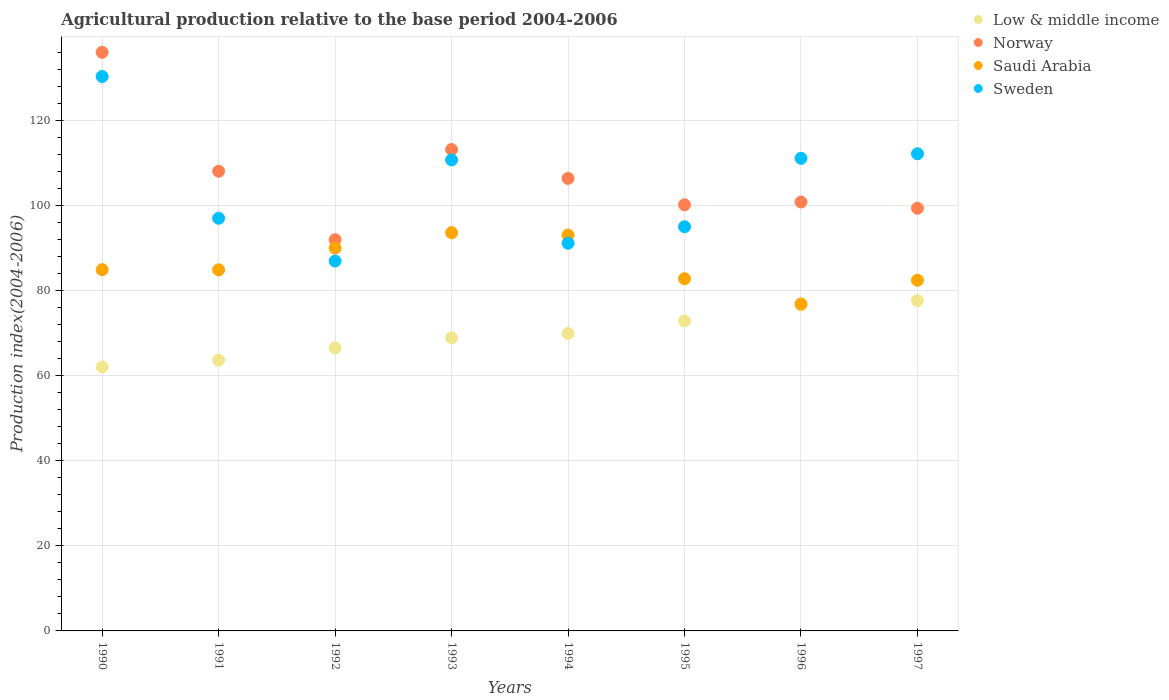How many different coloured dotlines are there?
Provide a short and direct response. 4. Is the number of dotlines equal to the number of legend labels?
Make the answer very short. Yes. What is the agricultural production index in Norway in 1992?
Provide a succinct answer. 91.99. Across all years, what is the maximum agricultural production index in Norway?
Offer a terse response. 136.05. Across all years, what is the minimum agricultural production index in Saudi Arabia?
Your answer should be compact. 76.88. In which year was the agricultural production index in Norway maximum?
Offer a terse response. 1990. What is the total agricultural production index in Norway in the graph?
Your answer should be compact. 856.15. What is the difference between the agricultural production index in Norway in 1994 and that in 1996?
Provide a short and direct response. 5.56. What is the difference between the agricultural production index in Norway in 1994 and the agricultural production index in Sweden in 1995?
Keep it short and to the point. 11.38. What is the average agricultural production index in Saudi Arabia per year?
Make the answer very short. 86.09. In the year 1991, what is the difference between the agricultural production index in Low & middle income and agricultural production index in Saudi Arabia?
Offer a terse response. -21.25. What is the ratio of the agricultural production index in Norway in 1990 to that in 1994?
Offer a terse response. 1.28. What is the difference between the highest and the second highest agricultural production index in Norway?
Make the answer very short. 22.86. What is the difference between the highest and the lowest agricultural production index in Low & middle income?
Your answer should be compact. 15.59. Is the sum of the agricultural production index in Sweden in 1990 and 1992 greater than the maximum agricultural production index in Saudi Arabia across all years?
Your response must be concise. Yes. Is it the case that in every year, the sum of the agricultural production index in Saudi Arabia and agricultural production index in Norway  is greater than the agricultural production index in Low & middle income?
Give a very brief answer. Yes. Is the agricultural production index in Norway strictly greater than the agricultural production index in Sweden over the years?
Provide a short and direct response. No. Is the agricultural production index in Saudi Arabia strictly less than the agricultural production index in Norway over the years?
Provide a short and direct response. Yes. How many dotlines are there?
Provide a short and direct response. 4. How many years are there in the graph?
Give a very brief answer. 8. Are the values on the major ticks of Y-axis written in scientific E-notation?
Provide a short and direct response. No. Does the graph contain any zero values?
Your answer should be very brief. No. Does the graph contain grids?
Give a very brief answer. Yes. How are the legend labels stacked?
Give a very brief answer. Vertical. What is the title of the graph?
Offer a very short reply. Agricultural production relative to the base period 2004-2006. What is the label or title of the X-axis?
Your answer should be very brief. Years. What is the label or title of the Y-axis?
Keep it short and to the point. Production index(2004-2006). What is the Production index(2004-2006) in Low & middle income in 1990?
Provide a succinct answer. 62.07. What is the Production index(2004-2006) in Norway in 1990?
Make the answer very short. 136.05. What is the Production index(2004-2006) of Saudi Arabia in 1990?
Ensure brevity in your answer.  84.94. What is the Production index(2004-2006) in Sweden in 1990?
Make the answer very short. 130.36. What is the Production index(2004-2006) in Low & middle income in 1991?
Offer a very short reply. 63.66. What is the Production index(2004-2006) in Norway in 1991?
Ensure brevity in your answer.  108.09. What is the Production index(2004-2006) of Saudi Arabia in 1991?
Offer a very short reply. 84.91. What is the Production index(2004-2006) in Sweden in 1991?
Keep it short and to the point. 97.03. What is the Production index(2004-2006) in Low & middle income in 1992?
Make the answer very short. 66.54. What is the Production index(2004-2006) of Norway in 1992?
Ensure brevity in your answer.  91.99. What is the Production index(2004-2006) in Saudi Arabia in 1992?
Offer a very short reply. 90.01. What is the Production index(2004-2006) in Sweden in 1992?
Provide a succinct answer. 86.97. What is the Production index(2004-2006) of Low & middle income in 1993?
Keep it short and to the point. 68.92. What is the Production index(2004-2006) of Norway in 1993?
Provide a succinct answer. 113.19. What is the Production index(2004-2006) of Saudi Arabia in 1993?
Offer a very short reply. 93.63. What is the Production index(2004-2006) in Sweden in 1993?
Your response must be concise. 110.75. What is the Production index(2004-2006) in Low & middle income in 1994?
Offer a terse response. 69.95. What is the Production index(2004-2006) of Norway in 1994?
Your response must be concise. 106.41. What is the Production index(2004-2006) of Saudi Arabia in 1994?
Make the answer very short. 93.08. What is the Production index(2004-2006) of Sweden in 1994?
Your response must be concise. 91.15. What is the Production index(2004-2006) of Low & middle income in 1995?
Provide a succinct answer. 72.89. What is the Production index(2004-2006) of Norway in 1995?
Make the answer very short. 100.19. What is the Production index(2004-2006) in Saudi Arabia in 1995?
Provide a short and direct response. 82.81. What is the Production index(2004-2006) of Sweden in 1995?
Your answer should be compact. 95.03. What is the Production index(2004-2006) of Low & middle income in 1996?
Ensure brevity in your answer.  76.63. What is the Production index(2004-2006) of Norway in 1996?
Offer a terse response. 100.85. What is the Production index(2004-2006) in Saudi Arabia in 1996?
Your response must be concise. 76.88. What is the Production index(2004-2006) of Sweden in 1996?
Offer a terse response. 111.12. What is the Production index(2004-2006) of Low & middle income in 1997?
Offer a very short reply. 77.67. What is the Production index(2004-2006) in Norway in 1997?
Offer a terse response. 99.38. What is the Production index(2004-2006) of Saudi Arabia in 1997?
Make the answer very short. 82.45. What is the Production index(2004-2006) in Sweden in 1997?
Give a very brief answer. 112.19. Across all years, what is the maximum Production index(2004-2006) in Low & middle income?
Give a very brief answer. 77.67. Across all years, what is the maximum Production index(2004-2006) of Norway?
Offer a very short reply. 136.05. Across all years, what is the maximum Production index(2004-2006) in Saudi Arabia?
Offer a terse response. 93.63. Across all years, what is the maximum Production index(2004-2006) in Sweden?
Offer a terse response. 130.36. Across all years, what is the minimum Production index(2004-2006) in Low & middle income?
Give a very brief answer. 62.07. Across all years, what is the minimum Production index(2004-2006) in Norway?
Offer a terse response. 91.99. Across all years, what is the minimum Production index(2004-2006) of Saudi Arabia?
Your response must be concise. 76.88. Across all years, what is the minimum Production index(2004-2006) of Sweden?
Offer a terse response. 86.97. What is the total Production index(2004-2006) in Low & middle income in the graph?
Give a very brief answer. 558.33. What is the total Production index(2004-2006) in Norway in the graph?
Provide a succinct answer. 856.15. What is the total Production index(2004-2006) in Saudi Arabia in the graph?
Make the answer very short. 688.71. What is the total Production index(2004-2006) in Sweden in the graph?
Provide a short and direct response. 834.6. What is the difference between the Production index(2004-2006) in Low & middle income in 1990 and that in 1991?
Your answer should be very brief. -1.59. What is the difference between the Production index(2004-2006) in Norway in 1990 and that in 1991?
Your response must be concise. 27.96. What is the difference between the Production index(2004-2006) of Saudi Arabia in 1990 and that in 1991?
Your answer should be compact. 0.03. What is the difference between the Production index(2004-2006) of Sweden in 1990 and that in 1991?
Keep it short and to the point. 33.33. What is the difference between the Production index(2004-2006) of Low & middle income in 1990 and that in 1992?
Provide a succinct answer. -4.47. What is the difference between the Production index(2004-2006) in Norway in 1990 and that in 1992?
Your answer should be compact. 44.06. What is the difference between the Production index(2004-2006) in Saudi Arabia in 1990 and that in 1992?
Provide a short and direct response. -5.07. What is the difference between the Production index(2004-2006) in Sweden in 1990 and that in 1992?
Ensure brevity in your answer.  43.39. What is the difference between the Production index(2004-2006) of Low & middle income in 1990 and that in 1993?
Provide a short and direct response. -6.85. What is the difference between the Production index(2004-2006) of Norway in 1990 and that in 1993?
Your answer should be compact. 22.86. What is the difference between the Production index(2004-2006) of Saudi Arabia in 1990 and that in 1993?
Offer a very short reply. -8.69. What is the difference between the Production index(2004-2006) in Sweden in 1990 and that in 1993?
Make the answer very short. 19.61. What is the difference between the Production index(2004-2006) in Low & middle income in 1990 and that in 1994?
Keep it short and to the point. -7.87. What is the difference between the Production index(2004-2006) of Norway in 1990 and that in 1994?
Provide a succinct answer. 29.64. What is the difference between the Production index(2004-2006) in Saudi Arabia in 1990 and that in 1994?
Provide a short and direct response. -8.14. What is the difference between the Production index(2004-2006) of Sweden in 1990 and that in 1994?
Provide a short and direct response. 39.21. What is the difference between the Production index(2004-2006) of Low & middle income in 1990 and that in 1995?
Make the answer very short. -10.82. What is the difference between the Production index(2004-2006) of Norway in 1990 and that in 1995?
Make the answer very short. 35.86. What is the difference between the Production index(2004-2006) in Saudi Arabia in 1990 and that in 1995?
Your answer should be compact. 2.13. What is the difference between the Production index(2004-2006) in Sweden in 1990 and that in 1995?
Offer a terse response. 35.33. What is the difference between the Production index(2004-2006) of Low & middle income in 1990 and that in 1996?
Keep it short and to the point. -14.56. What is the difference between the Production index(2004-2006) in Norway in 1990 and that in 1996?
Offer a terse response. 35.2. What is the difference between the Production index(2004-2006) in Saudi Arabia in 1990 and that in 1996?
Make the answer very short. 8.06. What is the difference between the Production index(2004-2006) in Sweden in 1990 and that in 1996?
Offer a terse response. 19.24. What is the difference between the Production index(2004-2006) in Low & middle income in 1990 and that in 1997?
Ensure brevity in your answer.  -15.59. What is the difference between the Production index(2004-2006) in Norway in 1990 and that in 1997?
Offer a terse response. 36.67. What is the difference between the Production index(2004-2006) in Saudi Arabia in 1990 and that in 1997?
Your answer should be very brief. 2.49. What is the difference between the Production index(2004-2006) of Sweden in 1990 and that in 1997?
Provide a succinct answer. 18.17. What is the difference between the Production index(2004-2006) of Low & middle income in 1991 and that in 1992?
Ensure brevity in your answer.  -2.88. What is the difference between the Production index(2004-2006) in Norway in 1991 and that in 1992?
Offer a terse response. 16.1. What is the difference between the Production index(2004-2006) in Sweden in 1991 and that in 1992?
Provide a succinct answer. 10.06. What is the difference between the Production index(2004-2006) of Low & middle income in 1991 and that in 1993?
Your answer should be compact. -5.26. What is the difference between the Production index(2004-2006) in Saudi Arabia in 1991 and that in 1993?
Offer a very short reply. -8.72. What is the difference between the Production index(2004-2006) of Sweden in 1991 and that in 1993?
Provide a short and direct response. -13.72. What is the difference between the Production index(2004-2006) in Low & middle income in 1991 and that in 1994?
Your response must be concise. -6.29. What is the difference between the Production index(2004-2006) in Norway in 1991 and that in 1994?
Keep it short and to the point. 1.68. What is the difference between the Production index(2004-2006) of Saudi Arabia in 1991 and that in 1994?
Offer a terse response. -8.17. What is the difference between the Production index(2004-2006) of Sweden in 1991 and that in 1994?
Offer a very short reply. 5.88. What is the difference between the Production index(2004-2006) of Low & middle income in 1991 and that in 1995?
Offer a terse response. -9.23. What is the difference between the Production index(2004-2006) of Saudi Arabia in 1991 and that in 1995?
Provide a short and direct response. 2.1. What is the difference between the Production index(2004-2006) in Sweden in 1991 and that in 1995?
Your answer should be compact. 2. What is the difference between the Production index(2004-2006) in Low & middle income in 1991 and that in 1996?
Give a very brief answer. -12.97. What is the difference between the Production index(2004-2006) of Norway in 1991 and that in 1996?
Keep it short and to the point. 7.24. What is the difference between the Production index(2004-2006) in Saudi Arabia in 1991 and that in 1996?
Ensure brevity in your answer.  8.03. What is the difference between the Production index(2004-2006) in Sweden in 1991 and that in 1996?
Your answer should be very brief. -14.09. What is the difference between the Production index(2004-2006) of Low & middle income in 1991 and that in 1997?
Provide a succinct answer. -14.01. What is the difference between the Production index(2004-2006) in Norway in 1991 and that in 1997?
Offer a very short reply. 8.71. What is the difference between the Production index(2004-2006) in Saudi Arabia in 1991 and that in 1997?
Provide a succinct answer. 2.46. What is the difference between the Production index(2004-2006) in Sweden in 1991 and that in 1997?
Make the answer very short. -15.16. What is the difference between the Production index(2004-2006) in Low & middle income in 1992 and that in 1993?
Offer a very short reply. -2.38. What is the difference between the Production index(2004-2006) in Norway in 1992 and that in 1993?
Ensure brevity in your answer.  -21.2. What is the difference between the Production index(2004-2006) in Saudi Arabia in 1992 and that in 1993?
Your answer should be very brief. -3.62. What is the difference between the Production index(2004-2006) of Sweden in 1992 and that in 1993?
Offer a terse response. -23.78. What is the difference between the Production index(2004-2006) of Low & middle income in 1992 and that in 1994?
Ensure brevity in your answer.  -3.41. What is the difference between the Production index(2004-2006) in Norway in 1992 and that in 1994?
Provide a short and direct response. -14.42. What is the difference between the Production index(2004-2006) in Saudi Arabia in 1992 and that in 1994?
Keep it short and to the point. -3.07. What is the difference between the Production index(2004-2006) in Sweden in 1992 and that in 1994?
Your response must be concise. -4.18. What is the difference between the Production index(2004-2006) of Low & middle income in 1992 and that in 1995?
Provide a short and direct response. -6.35. What is the difference between the Production index(2004-2006) of Norway in 1992 and that in 1995?
Your response must be concise. -8.2. What is the difference between the Production index(2004-2006) of Saudi Arabia in 1992 and that in 1995?
Your answer should be very brief. 7.2. What is the difference between the Production index(2004-2006) in Sweden in 1992 and that in 1995?
Provide a succinct answer. -8.06. What is the difference between the Production index(2004-2006) in Low & middle income in 1992 and that in 1996?
Ensure brevity in your answer.  -10.09. What is the difference between the Production index(2004-2006) in Norway in 1992 and that in 1996?
Your answer should be compact. -8.86. What is the difference between the Production index(2004-2006) in Saudi Arabia in 1992 and that in 1996?
Your answer should be very brief. 13.13. What is the difference between the Production index(2004-2006) of Sweden in 1992 and that in 1996?
Ensure brevity in your answer.  -24.15. What is the difference between the Production index(2004-2006) of Low & middle income in 1992 and that in 1997?
Your answer should be compact. -11.13. What is the difference between the Production index(2004-2006) of Norway in 1992 and that in 1997?
Offer a very short reply. -7.39. What is the difference between the Production index(2004-2006) in Saudi Arabia in 1992 and that in 1997?
Provide a succinct answer. 7.56. What is the difference between the Production index(2004-2006) of Sweden in 1992 and that in 1997?
Your answer should be very brief. -25.22. What is the difference between the Production index(2004-2006) of Low & middle income in 1993 and that in 1994?
Offer a terse response. -1.02. What is the difference between the Production index(2004-2006) of Norway in 1993 and that in 1994?
Give a very brief answer. 6.78. What is the difference between the Production index(2004-2006) in Saudi Arabia in 1993 and that in 1994?
Make the answer very short. 0.55. What is the difference between the Production index(2004-2006) of Sweden in 1993 and that in 1994?
Your answer should be very brief. 19.6. What is the difference between the Production index(2004-2006) of Low & middle income in 1993 and that in 1995?
Offer a very short reply. -3.97. What is the difference between the Production index(2004-2006) in Norway in 1993 and that in 1995?
Your answer should be compact. 13. What is the difference between the Production index(2004-2006) of Saudi Arabia in 1993 and that in 1995?
Your answer should be very brief. 10.82. What is the difference between the Production index(2004-2006) in Sweden in 1993 and that in 1995?
Your answer should be compact. 15.72. What is the difference between the Production index(2004-2006) in Low & middle income in 1993 and that in 1996?
Keep it short and to the point. -7.71. What is the difference between the Production index(2004-2006) in Norway in 1993 and that in 1996?
Your answer should be compact. 12.34. What is the difference between the Production index(2004-2006) of Saudi Arabia in 1993 and that in 1996?
Your answer should be compact. 16.75. What is the difference between the Production index(2004-2006) of Sweden in 1993 and that in 1996?
Ensure brevity in your answer.  -0.37. What is the difference between the Production index(2004-2006) in Low & middle income in 1993 and that in 1997?
Your answer should be very brief. -8.74. What is the difference between the Production index(2004-2006) in Norway in 1993 and that in 1997?
Offer a very short reply. 13.81. What is the difference between the Production index(2004-2006) of Saudi Arabia in 1993 and that in 1997?
Make the answer very short. 11.18. What is the difference between the Production index(2004-2006) of Sweden in 1993 and that in 1997?
Offer a terse response. -1.44. What is the difference between the Production index(2004-2006) of Low & middle income in 1994 and that in 1995?
Your answer should be very brief. -2.95. What is the difference between the Production index(2004-2006) of Norway in 1994 and that in 1995?
Provide a succinct answer. 6.22. What is the difference between the Production index(2004-2006) of Saudi Arabia in 1994 and that in 1995?
Your answer should be very brief. 10.27. What is the difference between the Production index(2004-2006) of Sweden in 1994 and that in 1995?
Your response must be concise. -3.88. What is the difference between the Production index(2004-2006) of Low & middle income in 1994 and that in 1996?
Offer a very short reply. -6.68. What is the difference between the Production index(2004-2006) of Norway in 1994 and that in 1996?
Provide a short and direct response. 5.56. What is the difference between the Production index(2004-2006) of Saudi Arabia in 1994 and that in 1996?
Your answer should be compact. 16.2. What is the difference between the Production index(2004-2006) of Sweden in 1994 and that in 1996?
Give a very brief answer. -19.97. What is the difference between the Production index(2004-2006) of Low & middle income in 1994 and that in 1997?
Your answer should be compact. -7.72. What is the difference between the Production index(2004-2006) in Norway in 1994 and that in 1997?
Your response must be concise. 7.03. What is the difference between the Production index(2004-2006) in Saudi Arabia in 1994 and that in 1997?
Offer a very short reply. 10.63. What is the difference between the Production index(2004-2006) of Sweden in 1994 and that in 1997?
Your answer should be very brief. -21.04. What is the difference between the Production index(2004-2006) of Low & middle income in 1995 and that in 1996?
Your answer should be very brief. -3.74. What is the difference between the Production index(2004-2006) of Norway in 1995 and that in 1996?
Make the answer very short. -0.66. What is the difference between the Production index(2004-2006) in Saudi Arabia in 1995 and that in 1996?
Provide a short and direct response. 5.93. What is the difference between the Production index(2004-2006) of Sweden in 1995 and that in 1996?
Your answer should be very brief. -16.09. What is the difference between the Production index(2004-2006) of Low & middle income in 1995 and that in 1997?
Your response must be concise. -4.77. What is the difference between the Production index(2004-2006) of Norway in 1995 and that in 1997?
Provide a short and direct response. 0.81. What is the difference between the Production index(2004-2006) in Saudi Arabia in 1995 and that in 1997?
Offer a very short reply. 0.36. What is the difference between the Production index(2004-2006) in Sweden in 1995 and that in 1997?
Ensure brevity in your answer.  -17.16. What is the difference between the Production index(2004-2006) in Low & middle income in 1996 and that in 1997?
Give a very brief answer. -1.04. What is the difference between the Production index(2004-2006) in Norway in 1996 and that in 1997?
Ensure brevity in your answer.  1.47. What is the difference between the Production index(2004-2006) of Saudi Arabia in 1996 and that in 1997?
Your answer should be very brief. -5.57. What is the difference between the Production index(2004-2006) of Sweden in 1996 and that in 1997?
Provide a short and direct response. -1.07. What is the difference between the Production index(2004-2006) in Low & middle income in 1990 and the Production index(2004-2006) in Norway in 1991?
Your answer should be very brief. -46.02. What is the difference between the Production index(2004-2006) in Low & middle income in 1990 and the Production index(2004-2006) in Saudi Arabia in 1991?
Offer a very short reply. -22.84. What is the difference between the Production index(2004-2006) of Low & middle income in 1990 and the Production index(2004-2006) of Sweden in 1991?
Ensure brevity in your answer.  -34.96. What is the difference between the Production index(2004-2006) in Norway in 1990 and the Production index(2004-2006) in Saudi Arabia in 1991?
Keep it short and to the point. 51.14. What is the difference between the Production index(2004-2006) of Norway in 1990 and the Production index(2004-2006) of Sweden in 1991?
Ensure brevity in your answer.  39.02. What is the difference between the Production index(2004-2006) of Saudi Arabia in 1990 and the Production index(2004-2006) of Sweden in 1991?
Your response must be concise. -12.09. What is the difference between the Production index(2004-2006) in Low & middle income in 1990 and the Production index(2004-2006) in Norway in 1992?
Ensure brevity in your answer.  -29.92. What is the difference between the Production index(2004-2006) of Low & middle income in 1990 and the Production index(2004-2006) of Saudi Arabia in 1992?
Offer a terse response. -27.94. What is the difference between the Production index(2004-2006) in Low & middle income in 1990 and the Production index(2004-2006) in Sweden in 1992?
Provide a succinct answer. -24.9. What is the difference between the Production index(2004-2006) of Norway in 1990 and the Production index(2004-2006) of Saudi Arabia in 1992?
Provide a short and direct response. 46.04. What is the difference between the Production index(2004-2006) in Norway in 1990 and the Production index(2004-2006) in Sweden in 1992?
Offer a terse response. 49.08. What is the difference between the Production index(2004-2006) of Saudi Arabia in 1990 and the Production index(2004-2006) of Sweden in 1992?
Provide a succinct answer. -2.03. What is the difference between the Production index(2004-2006) of Low & middle income in 1990 and the Production index(2004-2006) of Norway in 1993?
Your response must be concise. -51.12. What is the difference between the Production index(2004-2006) of Low & middle income in 1990 and the Production index(2004-2006) of Saudi Arabia in 1993?
Your response must be concise. -31.56. What is the difference between the Production index(2004-2006) of Low & middle income in 1990 and the Production index(2004-2006) of Sweden in 1993?
Give a very brief answer. -48.68. What is the difference between the Production index(2004-2006) in Norway in 1990 and the Production index(2004-2006) in Saudi Arabia in 1993?
Provide a short and direct response. 42.42. What is the difference between the Production index(2004-2006) in Norway in 1990 and the Production index(2004-2006) in Sweden in 1993?
Ensure brevity in your answer.  25.3. What is the difference between the Production index(2004-2006) in Saudi Arabia in 1990 and the Production index(2004-2006) in Sweden in 1993?
Your answer should be compact. -25.81. What is the difference between the Production index(2004-2006) of Low & middle income in 1990 and the Production index(2004-2006) of Norway in 1994?
Your answer should be compact. -44.34. What is the difference between the Production index(2004-2006) in Low & middle income in 1990 and the Production index(2004-2006) in Saudi Arabia in 1994?
Ensure brevity in your answer.  -31.01. What is the difference between the Production index(2004-2006) in Low & middle income in 1990 and the Production index(2004-2006) in Sweden in 1994?
Your answer should be very brief. -29.08. What is the difference between the Production index(2004-2006) of Norway in 1990 and the Production index(2004-2006) of Saudi Arabia in 1994?
Offer a terse response. 42.97. What is the difference between the Production index(2004-2006) in Norway in 1990 and the Production index(2004-2006) in Sweden in 1994?
Keep it short and to the point. 44.9. What is the difference between the Production index(2004-2006) in Saudi Arabia in 1990 and the Production index(2004-2006) in Sweden in 1994?
Give a very brief answer. -6.21. What is the difference between the Production index(2004-2006) of Low & middle income in 1990 and the Production index(2004-2006) of Norway in 1995?
Keep it short and to the point. -38.12. What is the difference between the Production index(2004-2006) of Low & middle income in 1990 and the Production index(2004-2006) of Saudi Arabia in 1995?
Ensure brevity in your answer.  -20.74. What is the difference between the Production index(2004-2006) of Low & middle income in 1990 and the Production index(2004-2006) of Sweden in 1995?
Offer a very short reply. -32.96. What is the difference between the Production index(2004-2006) of Norway in 1990 and the Production index(2004-2006) of Saudi Arabia in 1995?
Provide a succinct answer. 53.24. What is the difference between the Production index(2004-2006) in Norway in 1990 and the Production index(2004-2006) in Sweden in 1995?
Your answer should be very brief. 41.02. What is the difference between the Production index(2004-2006) of Saudi Arabia in 1990 and the Production index(2004-2006) of Sweden in 1995?
Provide a short and direct response. -10.09. What is the difference between the Production index(2004-2006) in Low & middle income in 1990 and the Production index(2004-2006) in Norway in 1996?
Provide a short and direct response. -38.78. What is the difference between the Production index(2004-2006) in Low & middle income in 1990 and the Production index(2004-2006) in Saudi Arabia in 1996?
Give a very brief answer. -14.81. What is the difference between the Production index(2004-2006) in Low & middle income in 1990 and the Production index(2004-2006) in Sweden in 1996?
Give a very brief answer. -49.05. What is the difference between the Production index(2004-2006) of Norway in 1990 and the Production index(2004-2006) of Saudi Arabia in 1996?
Offer a terse response. 59.17. What is the difference between the Production index(2004-2006) of Norway in 1990 and the Production index(2004-2006) of Sweden in 1996?
Offer a very short reply. 24.93. What is the difference between the Production index(2004-2006) in Saudi Arabia in 1990 and the Production index(2004-2006) in Sweden in 1996?
Your answer should be compact. -26.18. What is the difference between the Production index(2004-2006) of Low & middle income in 1990 and the Production index(2004-2006) of Norway in 1997?
Offer a terse response. -37.31. What is the difference between the Production index(2004-2006) of Low & middle income in 1990 and the Production index(2004-2006) of Saudi Arabia in 1997?
Your answer should be compact. -20.38. What is the difference between the Production index(2004-2006) of Low & middle income in 1990 and the Production index(2004-2006) of Sweden in 1997?
Provide a short and direct response. -50.12. What is the difference between the Production index(2004-2006) of Norway in 1990 and the Production index(2004-2006) of Saudi Arabia in 1997?
Make the answer very short. 53.6. What is the difference between the Production index(2004-2006) in Norway in 1990 and the Production index(2004-2006) in Sweden in 1997?
Make the answer very short. 23.86. What is the difference between the Production index(2004-2006) of Saudi Arabia in 1990 and the Production index(2004-2006) of Sweden in 1997?
Offer a terse response. -27.25. What is the difference between the Production index(2004-2006) of Low & middle income in 1991 and the Production index(2004-2006) of Norway in 1992?
Provide a succinct answer. -28.33. What is the difference between the Production index(2004-2006) of Low & middle income in 1991 and the Production index(2004-2006) of Saudi Arabia in 1992?
Ensure brevity in your answer.  -26.35. What is the difference between the Production index(2004-2006) in Low & middle income in 1991 and the Production index(2004-2006) in Sweden in 1992?
Make the answer very short. -23.31. What is the difference between the Production index(2004-2006) of Norway in 1991 and the Production index(2004-2006) of Saudi Arabia in 1992?
Your response must be concise. 18.08. What is the difference between the Production index(2004-2006) in Norway in 1991 and the Production index(2004-2006) in Sweden in 1992?
Offer a very short reply. 21.12. What is the difference between the Production index(2004-2006) of Saudi Arabia in 1991 and the Production index(2004-2006) of Sweden in 1992?
Offer a terse response. -2.06. What is the difference between the Production index(2004-2006) in Low & middle income in 1991 and the Production index(2004-2006) in Norway in 1993?
Offer a very short reply. -49.53. What is the difference between the Production index(2004-2006) in Low & middle income in 1991 and the Production index(2004-2006) in Saudi Arabia in 1993?
Ensure brevity in your answer.  -29.97. What is the difference between the Production index(2004-2006) of Low & middle income in 1991 and the Production index(2004-2006) of Sweden in 1993?
Provide a succinct answer. -47.09. What is the difference between the Production index(2004-2006) in Norway in 1991 and the Production index(2004-2006) in Saudi Arabia in 1993?
Offer a terse response. 14.46. What is the difference between the Production index(2004-2006) of Norway in 1991 and the Production index(2004-2006) of Sweden in 1993?
Your answer should be very brief. -2.66. What is the difference between the Production index(2004-2006) in Saudi Arabia in 1991 and the Production index(2004-2006) in Sweden in 1993?
Keep it short and to the point. -25.84. What is the difference between the Production index(2004-2006) of Low & middle income in 1991 and the Production index(2004-2006) of Norway in 1994?
Provide a short and direct response. -42.75. What is the difference between the Production index(2004-2006) in Low & middle income in 1991 and the Production index(2004-2006) in Saudi Arabia in 1994?
Provide a succinct answer. -29.42. What is the difference between the Production index(2004-2006) of Low & middle income in 1991 and the Production index(2004-2006) of Sweden in 1994?
Your answer should be compact. -27.49. What is the difference between the Production index(2004-2006) of Norway in 1991 and the Production index(2004-2006) of Saudi Arabia in 1994?
Ensure brevity in your answer.  15.01. What is the difference between the Production index(2004-2006) of Norway in 1991 and the Production index(2004-2006) of Sweden in 1994?
Your response must be concise. 16.94. What is the difference between the Production index(2004-2006) of Saudi Arabia in 1991 and the Production index(2004-2006) of Sweden in 1994?
Offer a terse response. -6.24. What is the difference between the Production index(2004-2006) of Low & middle income in 1991 and the Production index(2004-2006) of Norway in 1995?
Your answer should be very brief. -36.53. What is the difference between the Production index(2004-2006) of Low & middle income in 1991 and the Production index(2004-2006) of Saudi Arabia in 1995?
Provide a short and direct response. -19.15. What is the difference between the Production index(2004-2006) of Low & middle income in 1991 and the Production index(2004-2006) of Sweden in 1995?
Your answer should be compact. -31.37. What is the difference between the Production index(2004-2006) of Norway in 1991 and the Production index(2004-2006) of Saudi Arabia in 1995?
Keep it short and to the point. 25.28. What is the difference between the Production index(2004-2006) in Norway in 1991 and the Production index(2004-2006) in Sweden in 1995?
Give a very brief answer. 13.06. What is the difference between the Production index(2004-2006) in Saudi Arabia in 1991 and the Production index(2004-2006) in Sweden in 1995?
Provide a short and direct response. -10.12. What is the difference between the Production index(2004-2006) of Low & middle income in 1991 and the Production index(2004-2006) of Norway in 1996?
Provide a succinct answer. -37.19. What is the difference between the Production index(2004-2006) in Low & middle income in 1991 and the Production index(2004-2006) in Saudi Arabia in 1996?
Give a very brief answer. -13.22. What is the difference between the Production index(2004-2006) in Low & middle income in 1991 and the Production index(2004-2006) in Sweden in 1996?
Offer a very short reply. -47.46. What is the difference between the Production index(2004-2006) of Norway in 1991 and the Production index(2004-2006) of Saudi Arabia in 1996?
Your answer should be very brief. 31.21. What is the difference between the Production index(2004-2006) of Norway in 1991 and the Production index(2004-2006) of Sweden in 1996?
Make the answer very short. -3.03. What is the difference between the Production index(2004-2006) in Saudi Arabia in 1991 and the Production index(2004-2006) in Sweden in 1996?
Your answer should be very brief. -26.21. What is the difference between the Production index(2004-2006) of Low & middle income in 1991 and the Production index(2004-2006) of Norway in 1997?
Offer a terse response. -35.72. What is the difference between the Production index(2004-2006) in Low & middle income in 1991 and the Production index(2004-2006) in Saudi Arabia in 1997?
Ensure brevity in your answer.  -18.79. What is the difference between the Production index(2004-2006) of Low & middle income in 1991 and the Production index(2004-2006) of Sweden in 1997?
Your response must be concise. -48.53. What is the difference between the Production index(2004-2006) of Norway in 1991 and the Production index(2004-2006) of Saudi Arabia in 1997?
Offer a terse response. 25.64. What is the difference between the Production index(2004-2006) of Norway in 1991 and the Production index(2004-2006) of Sweden in 1997?
Provide a short and direct response. -4.1. What is the difference between the Production index(2004-2006) of Saudi Arabia in 1991 and the Production index(2004-2006) of Sweden in 1997?
Give a very brief answer. -27.28. What is the difference between the Production index(2004-2006) of Low & middle income in 1992 and the Production index(2004-2006) of Norway in 1993?
Provide a succinct answer. -46.65. What is the difference between the Production index(2004-2006) of Low & middle income in 1992 and the Production index(2004-2006) of Saudi Arabia in 1993?
Provide a short and direct response. -27.09. What is the difference between the Production index(2004-2006) of Low & middle income in 1992 and the Production index(2004-2006) of Sweden in 1993?
Offer a terse response. -44.21. What is the difference between the Production index(2004-2006) in Norway in 1992 and the Production index(2004-2006) in Saudi Arabia in 1993?
Ensure brevity in your answer.  -1.64. What is the difference between the Production index(2004-2006) in Norway in 1992 and the Production index(2004-2006) in Sweden in 1993?
Offer a very short reply. -18.76. What is the difference between the Production index(2004-2006) in Saudi Arabia in 1992 and the Production index(2004-2006) in Sweden in 1993?
Provide a succinct answer. -20.74. What is the difference between the Production index(2004-2006) in Low & middle income in 1992 and the Production index(2004-2006) in Norway in 1994?
Give a very brief answer. -39.87. What is the difference between the Production index(2004-2006) in Low & middle income in 1992 and the Production index(2004-2006) in Saudi Arabia in 1994?
Make the answer very short. -26.54. What is the difference between the Production index(2004-2006) of Low & middle income in 1992 and the Production index(2004-2006) of Sweden in 1994?
Offer a terse response. -24.61. What is the difference between the Production index(2004-2006) of Norway in 1992 and the Production index(2004-2006) of Saudi Arabia in 1994?
Make the answer very short. -1.09. What is the difference between the Production index(2004-2006) of Norway in 1992 and the Production index(2004-2006) of Sweden in 1994?
Your answer should be compact. 0.84. What is the difference between the Production index(2004-2006) of Saudi Arabia in 1992 and the Production index(2004-2006) of Sweden in 1994?
Provide a succinct answer. -1.14. What is the difference between the Production index(2004-2006) of Low & middle income in 1992 and the Production index(2004-2006) of Norway in 1995?
Give a very brief answer. -33.65. What is the difference between the Production index(2004-2006) in Low & middle income in 1992 and the Production index(2004-2006) in Saudi Arabia in 1995?
Offer a very short reply. -16.27. What is the difference between the Production index(2004-2006) of Low & middle income in 1992 and the Production index(2004-2006) of Sweden in 1995?
Offer a very short reply. -28.49. What is the difference between the Production index(2004-2006) in Norway in 1992 and the Production index(2004-2006) in Saudi Arabia in 1995?
Offer a very short reply. 9.18. What is the difference between the Production index(2004-2006) of Norway in 1992 and the Production index(2004-2006) of Sweden in 1995?
Keep it short and to the point. -3.04. What is the difference between the Production index(2004-2006) in Saudi Arabia in 1992 and the Production index(2004-2006) in Sweden in 1995?
Provide a short and direct response. -5.02. What is the difference between the Production index(2004-2006) in Low & middle income in 1992 and the Production index(2004-2006) in Norway in 1996?
Keep it short and to the point. -34.31. What is the difference between the Production index(2004-2006) of Low & middle income in 1992 and the Production index(2004-2006) of Saudi Arabia in 1996?
Ensure brevity in your answer.  -10.34. What is the difference between the Production index(2004-2006) of Low & middle income in 1992 and the Production index(2004-2006) of Sweden in 1996?
Give a very brief answer. -44.58. What is the difference between the Production index(2004-2006) of Norway in 1992 and the Production index(2004-2006) of Saudi Arabia in 1996?
Your response must be concise. 15.11. What is the difference between the Production index(2004-2006) in Norway in 1992 and the Production index(2004-2006) in Sweden in 1996?
Make the answer very short. -19.13. What is the difference between the Production index(2004-2006) in Saudi Arabia in 1992 and the Production index(2004-2006) in Sweden in 1996?
Make the answer very short. -21.11. What is the difference between the Production index(2004-2006) in Low & middle income in 1992 and the Production index(2004-2006) in Norway in 1997?
Keep it short and to the point. -32.84. What is the difference between the Production index(2004-2006) of Low & middle income in 1992 and the Production index(2004-2006) of Saudi Arabia in 1997?
Ensure brevity in your answer.  -15.91. What is the difference between the Production index(2004-2006) in Low & middle income in 1992 and the Production index(2004-2006) in Sweden in 1997?
Offer a very short reply. -45.65. What is the difference between the Production index(2004-2006) of Norway in 1992 and the Production index(2004-2006) of Saudi Arabia in 1997?
Keep it short and to the point. 9.54. What is the difference between the Production index(2004-2006) of Norway in 1992 and the Production index(2004-2006) of Sweden in 1997?
Your response must be concise. -20.2. What is the difference between the Production index(2004-2006) in Saudi Arabia in 1992 and the Production index(2004-2006) in Sweden in 1997?
Your answer should be compact. -22.18. What is the difference between the Production index(2004-2006) of Low & middle income in 1993 and the Production index(2004-2006) of Norway in 1994?
Provide a succinct answer. -37.49. What is the difference between the Production index(2004-2006) in Low & middle income in 1993 and the Production index(2004-2006) in Saudi Arabia in 1994?
Offer a very short reply. -24.16. What is the difference between the Production index(2004-2006) in Low & middle income in 1993 and the Production index(2004-2006) in Sweden in 1994?
Ensure brevity in your answer.  -22.23. What is the difference between the Production index(2004-2006) in Norway in 1993 and the Production index(2004-2006) in Saudi Arabia in 1994?
Offer a very short reply. 20.11. What is the difference between the Production index(2004-2006) of Norway in 1993 and the Production index(2004-2006) of Sweden in 1994?
Your answer should be compact. 22.04. What is the difference between the Production index(2004-2006) in Saudi Arabia in 1993 and the Production index(2004-2006) in Sweden in 1994?
Keep it short and to the point. 2.48. What is the difference between the Production index(2004-2006) in Low & middle income in 1993 and the Production index(2004-2006) in Norway in 1995?
Your answer should be very brief. -31.27. What is the difference between the Production index(2004-2006) of Low & middle income in 1993 and the Production index(2004-2006) of Saudi Arabia in 1995?
Your answer should be compact. -13.89. What is the difference between the Production index(2004-2006) in Low & middle income in 1993 and the Production index(2004-2006) in Sweden in 1995?
Offer a terse response. -26.11. What is the difference between the Production index(2004-2006) in Norway in 1993 and the Production index(2004-2006) in Saudi Arabia in 1995?
Offer a very short reply. 30.38. What is the difference between the Production index(2004-2006) in Norway in 1993 and the Production index(2004-2006) in Sweden in 1995?
Keep it short and to the point. 18.16. What is the difference between the Production index(2004-2006) of Saudi Arabia in 1993 and the Production index(2004-2006) of Sweden in 1995?
Your answer should be compact. -1.4. What is the difference between the Production index(2004-2006) in Low & middle income in 1993 and the Production index(2004-2006) in Norway in 1996?
Provide a short and direct response. -31.93. What is the difference between the Production index(2004-2006) in Low & middle income in 1993 and the Production index(2004-2006) in Saudi Arabia in 1996?
Provide a short and direct response. -7.96. What is the difference between the Production index(2004-2006) in Low & middle income in 1993 and the Production index(2004-2006) in Sweden in 1996?
Your response must be concise. -42.2. What is the difference between the Production index(2004-2006) of Norway in 1993 and the Production index(2004-2006) of Saudi Arabia in 1996?
Offer a very short reply. 36.31. What is the difference between the Production index(2004-2006) in Norway in 1993 and the Production index(2004-2006) in Sweden in 1996?
Provide a succinct answer. 2.07. What is the difference between the Production index(2004-2006) of Saudi Arabia in 1993 and the Production index(2004-2006) of Sweden in 1996?
Give a very brief answer. -17.49. What is the difference between the Production index(2004-2006) of Low & middle income in 1993 and the Production index(2004-2006) of Norway in 1997?
Provide a succinct answer. -30.46. What is the difference between the Production index(2004-2006) in Low & middle income in 1993 and the Production index(2004-2006) in Saudi Arabia in 1997?
Provide a succinct answer. -13.53. What is the difference between the Production index(2004-2006) in Low & middle income in 1993 and the Production index(2004-2006) in Sweden in 1997?
Offer a terse response. -43.27. What is the difference between the Production index(2004-2006) of Norway in 1993 and the Production index(2004-2006) of Saudi Arabia in 1997?
Provide a short and direct response. 30.74. What is the difference between the Production index(2004-2006) in Saudi Arabia in 1993 and the Production index(2004-2006) in Sweden in 1997?
Provide a short and direct response. -18.56. What is the difference between the Production index(2004-2006) in Low & middle income in 1994 and the Production index(2004-2006) in Norway in 1995?
Ensure brevity in your answer.  -30.24. What is the difference between the Production index(2004-2006) in Low & middle income in 1994 and the Production index(2004-2006) in Saudi Arabia in 1995?
Your response must be concise. -12.86. What is the difference between the Production index(2004-2006) in Low & middle income in 1994 and the Production index(2004-2006) in Sweden in 1995?
Provide a short and direct response. -25.08. What is the difference between the Production index(2004-2006) in Norway in 1994 and the Production index(2004-2006) in Saudi Arabia in 1995?
Give a very brief answer. 23.6. What is the difference between the Production index(2004-2006) of Norway in 1994 and the Production index(2004-2006) of Sweden in 1995?
Give a very brief answer. 11.38. What is the difference between the Production index(2004-2006) in Saudi Arabia in 1994 and the Production index(2004-2006) in Sweden in 1995?
Your answer should be very brief. -1.95. What is the difference between the Production index(2004-2006) in Low & middle income in 1994 and the Production index(2004-2006) in Norway in 1996?
Keep it short and to the point. -30.9. What is the difference between the Production index(2004-2006) of Low & middle income in 1994 and the Production index(2004-2006) of Saudi Arabia in 1996?
Ensure brevity in your answer.  -6.93. What is the difference between the Production index(2004-2006) of Low & middle income in 1994 and the Production index(2004-2006) of Sweden in 1996?
Give a very brief answer. -41.17. What is the difference between the Production index(2004-2006) of Norway in 1994 and the Production index(2004-2006) of Saudi Arabia in 1996?
Ensure brevity in your answer.  29.53. What is the difference between the Production index(2004-2006) of Norway in 1994 and the Production index(2004-2006) of Sweden in 1996?
Provide a succinct answer. -4.71. What is the difference between the Production index(2004-2006) in Saudi Arabia in 1994 and the Production index(2004-2006) in Sweden in 1996?
Make the answer very short. -18.04. What is the difference between the Production index(2004-2006) in Low & middle income in 1994 and the Production index(2004-2006) in Norway in 1997?
Your response must be concise. -29.43. What is the difference between the Production index(2004-2006) of Low & middle income in 1994 and the Production index(2004-2006) of Saudi Arabia in 1997?
Ensure brevity in your answer.  -12.5. What is the difference between the Production index(2004-2006) of Low & middle income in 1994 and the Production index(2004-2006) of Sweden in 1997?
Offer a very short reply. -42.24. What is the difference between the Production index(2004-2006) of Norway in 1994 and the Production index(2004-2006) of Saudi Arabia in 1997?
Make the answer very short. 23.96. What is the difference between the Production index(2004-2006) in Norway in 1994 and the Production index(2004-2006) in Sweden in 1997?
Your answer should be compact. -5.78. What is the difference between the Production index(2004-2006) in Saudi Arabia in 1994 and the Production index(2004-2006) in Sweden in 1997?
Make the answer very short. -19.11. What is the difference between the Production index(2004-2006) of Low & middle income in 1995 and the Production index(2004-2006) of Norway in 1996?
Your response must be concise. -27.96. What is the difference between the Production index(2004-2006) in Low & middle income in 1995 and the Production index(2004-2006) in Saudi Arabia in 1996?
Ensure brevity in your answer.  -3.99. What is the difference between the Production index(2004-2006) in Low & middle income in 1995 and the Production index(2004-2006) in Sweden in 1996?
Keep it short and to the point. -38.23. What is the difference between the Production index(2004-2006) of Norway in 1995 and the Production index(2004-2006) of Saudi Arabia in 1996?
Provide a succinct answer. 23.31. What is the difference between the Production index(2004-2006) of Norway in 1995 and the Production index(2004-2006) of Sweden in 1996?
Your response must be concise. -10.93. What is the difference between the Production index(2004-2006) of Saudi Arabia in 1995 and the Production index(2004-2006) of Sweden in 1996?
Your answer should be compact. -28.31. What is the difference between the Production index(2004-2006) of Low & middle income in 1995 and the Production index(2004-2006) of Norway in 1997?
Your answer should be very brief. -26.49. What is the difference between the Production index(2004-2006) of Low & middle income in 1995 and the Production index(2004-2006) of Saudi Arabia in 1997?
Give a very brief answer. -9.56. What is the difference between the Production index(2004-2006) in Low & middle income in 1995 and the Production index(2004-2006) in Sweden in 1997?
Your answer should be very brief. -39.3. What is the difference between the Production index(2004-2006) of Norway in 1995 and the Production index(2004-2006) of Saudi Arabia in 1997?
Ensure brevity in your answer.  17.74. What is the difference between the Production index(2004-2006) of Norway in 1995 and the Production index(2004-2006) of Sweden in 1997?
Your answer should be compact. -12. What is the difference between the Production index(2004-2006) of Saudi Arabia in 1995 and the Production index(2004-2006) of Sweden in 1997?
Offer a terse response. -29.38. What is the difference between the Production index(2004-2006) in Low & middle income in 1996 and the Production index(2004-2006) in Norway in 1997?
Provide a succinct answer. -22.75. What is the difference between the Production index(2004-2006) in Low & middle income in 1996 and the Production index(2004-2006) in Saudi Arabia in 1997?
Provide a short and direct response. -5.82. What is the difference between the Production index(2004-2006) in Low & middle income in 1996 and the Production index(2004-2006) in Sweden in 1997?
Offer a very short reply. -35.56. What is the difference between the Production index(2004-2006) in Norway in 1996 and the Production index(2004-2006) in Saudi Arabia in 1997?
Make the answer very short. 18.4. What is the difference between the Production index(2004-2006) of Norway in 1996 and the Production index(2004-2006) of Sweden in 1997?
Provide a short and direct response. -11.34. What is the difference between the Production index(2004-2006) in Saudi Arabia in 1996 and the Production index(2004-2006) in Sweden in 1997?
Make the answer very short. -35.31. What is the average Production index(2004-2006) of Low & middle income per year?
Give a very brief answer. 69.79. What is the average Production index(2004-2006) in Norway per year?
Offer a terse response. 107.02. What is the average Production index(2004-2006) in Saudi Arabia per year?
Give a very brief answer. 86.09. What is the average Production index(2004-2006) of Sweden per year?
Provide a succinct answer. 104.33. In the year 1990, what is the difference between the Production index(2004-2006) of Low & middle income and Production index(2004-2006) of Norway?
Provide a succinct answer. -73.98. In the year 1990, what is the difference between the Production index(2004-2006) of Low & middle income and Production index(2004-2006) of Saudi Arabia?
Provide a succinct answer. -22.87. In the year 1990, what is the difference between the Production index(2004-2006) of Low & middle income and Production index(2004-2006) of Sweden?
Make the answer very short. -68.29. In the year 1990, what is the difference between the Production index(2004-2006) in Norway and Production index(2004-2006) in Saudi Arabia?
Ensure brevity in your answer.  51.11. In the year 1990, what is the difference between the Production index(2004-2006) of Norway and Production index(2004-2006) of Sweden?
Your response must be concise. 5.69. In the year 1990, what is the difference between the Production index(2004-2006) of Saudi Arabia and Production index(2004-2006) of Sweden?
Make the answer very short. -45.42. In the year 1991, what is the difference between the Production index(2004-2006) in Low & middle income and Production index(2004-2006) in Norway?
Your response must be concise. -44.43. In the year 1991, what is the difference between the Production index(2004-2006) of Low & middle income and Production index(2004-2006) of Saudi Arabia?
Provide a succinct answer. -21.25. In the year 1991, what is the difference between the Production index(2004-2006) in Low & middle income and Production index(2004-2006) in Sweden?
Provide a short and direct response. -33.37. In the year 1991, what is the difference between the Production index(2004-2006) of Norway and Production index(2004-2006) of Saudi Arabia?
Give a very brief answer. 23.18. In the year 1991, what is the difference between the Production index(2004-2006) of Norway and Production index(2004-2006) of Sweden?
Make the answer very short. 11.06. In the year 1991, what is the difference between the Production index(2004-2006) in Saudi Arabia and Production index(2004-2006) in Sweden?
Keep it short and to the point. -12.12. In the year 1992, what is the difference between the Production index(2004-2006) in Low & middle income and Production index(2004-2006) in Norway?
Provide a short and direct response. -25.45. In the year 1992, what is the difference between the Production index(2004-2006) in Low & middle income and Production index(2004-2006) in Saudi Arabia?
Provide a short and direct response. -23.47. In the year 1992, what is the difference between the Production index(2004-2006) of Low & middle income and Production index(2004-2006) of Sweden?
Give a very brief answer. -20.43. In the year 1992, what is the difference between the Production index(2004-2006) in Norway and Production index(2004-2006) in Saudi Arabia?
Give a very brief answer. 1.98. In the year 1992, what is the difference between the Production index(2004-2006) in Norway and Production index(2004-2006) in Sweden?
Provide a short and direct response. 5.02. In the year 1992, what is the difference between the Production index(2004-2006) in Saudi Arabia and Production index(2004-2006) in Sweden?
Give a very brief answer. 3.04. In the year 1993, what is the difference between the Production index(2004-2006) in Low & middle income and Production index(2004-2006) in Norway?
Offer a very short reply. -44.27. In the year 1993, what is the difference between the Production index(2004-2006) in Low & middle income and Production index(2004-2006) in Saudi Arabia?
Offer a terse response. -24.71. In the year 1993, what is the difference between the Production index(2004-2006) in Low & middle income and Production index(2004-2006) in Sweden?
Keep it short and to the point. -41.83. In the year 1993, what is the difference between the Production index(2004-2006) in Norway and Production index(2004-2006) in Saudi Arabia?
Provide a short and direct response. 19.56. In the year 1993, what is the difference between the Production index(2004-2006) of Norway and Production index(2004-2006) of Sweden?
Make the answer very short. 2.44. In the year 1993, what is the difference between the Production index(2004-2006) of Saudi Arabia and Production index(2004-2006) of Sweden?
Keep it short and to the point. -17.12. In the year 1994, what is the difference between the Production index(2004-2006) in Low & middle income and Production index(2004-2006) in Norway?
Provide a short and direct response. -36.46. In the year 1994, what is the difference between the Production index(2004-2006) in Low & middle income and Production index(2004-2006) in Saudi Arabia?
Offer a terse response. -23.13. In the year 1994, what is the difference between the Production index(2004-2006) in Low & middle income and Production index(2004-2006) in Sweden?
Keep it short and to the point. -21.2. In the year 1994, what is the difference between the Production index(2004-2006) of Norway and Production index(2004-2006) of Saudi Arabia?
Your response must be concise. 13.33. In the year 1994, what is the difference between the Production index(2004-2006) of Norway and Production index(2004-2006) of Sweden?
Offer a very short reply. 15.26. In the year 1994, what is the difference between the Production index(2004-2006) of Saudi Arabia and Production index(2004-2006) of Sweden?
Provide a succinct answer. 1.93. In the year 1995, what is the difference between the Production index(2004-2006) in Low & middle income and Production index(2004-2006) in Norway?
Keep it short and to the point. -27.3. In the year 1995, what is the difference between the Production index(2004-2006) of Low & middle income and Production index(2004-2006) of Saudi Arabia?
Your answer should be compact. -9.92. In the year 1995, what is the difference between the Production index(2004-2006) of Low & middle income and Production index(2004-2006) of Sweden?
Ensure brevity in your answer.  -22.14. In the year 1995, what is the difference between the Production index(2004-2006) in Norway and Production index(2004-2006) in Saudi Arabia?
Ensure brevity in your answer.  17.38. In the year 1995, what is the difference between the Production index(2004-2006) of Norway and Production index(2004-2006) of Sweden?
Provide a succinct answer. 5.16. In the year 1995, what is the difference between the Production index(2004-2006) of Saudi Arabia and Production index(2004-2006) of Sweden?
Make the answer very short. -12.22. In the year 1996, what is the difference between the Production index(2004-2006) in Low & middle income and Production index(2004-2006) in Norway?
Your response must be concise. -24.22. In the year 1996, what is the difference between the Production index(2004-2006) in Low & middle income and Production index(2004-2006) in Saudi Arabia?
Your answer should be very brief. -0.25. In the year 1996, what is the difference between the Production index(2004-2006) in Low & middle income and Production index(2004-2006) in Sweden?
Keep it short and to the point. -34.49. In the year 1996, what is the difference between the Production index(2004-2006) of Norway and Production index(2004-2006) of Saudi Arabia?
Provide a succinct answer. 23.97. In the year 1996, what is the difference between the Production index(2004-2006) of Norway and Production index(2004-2006) of Sweden?
Provide a succinct answer. -10.27. In the year 1996, what is the difference between the Production index(2004-2006) of Saudi Arabia and Production index(2004-2006) of Sweden?
Give a very brief answer. -34.24. In the year 1997, what is the difference between the Production index(2004-2006) of Low & middle income and Production index(2004-2006) of Norway?
Provide a succinct answer. -21.71. In the year 1997, what is the difference between the Production index(2004-2006) in Low & middle income and Production index(2004-2006) in Saudi Arabia?
Provide a succinct answer. -4.78. In the year 1997, what is the difference between the Production index(2004-2006) of Low & middle income and Production index(2004-2006) of Sweden?
Your answer should be compact. -34.52. In the year 1997, what is the difference between the Production index(2004-2006) in Norway and Production index(2004-2006) in Saudi Arabia?
Provide a short and direct response. 16.93. In the year 1997, what is the difference between the Production index(2004-2006) in Norway and Production index(2004-2006) in Sweden?
Offer a terse response. -12.81. In the year 1997, what is the difference between the Production index(2004-2006) of Saudi Arabia and Production index(2004-2006) of Sweden?
Provide a succinct answer. -29.74. What is the ratio of the Production index(2004-2006) of Low & middle income in 1990 to that in 1991?
Keep it short and to the point. 0.98. What is the ratio of the Production index(2004-2006) in Norway in 1990 to that in 1991?
Your answer should be very brief. 1.26. What is the ratio of the Production index(2004-2006) in Saudi Arabia in 1990 to that in 1991?
Offer a very short reply. 1. What is the ratio of the Production index(2004-2006) in Sweden in 1990 to that in 1991?
Make the answer very short. 1.34. What is the ratio of the Production index(2004-2006) in Low & middle income in 1990 to that in 1992?
Keep it short and to the point. 0.93. What is the ratio of the Production index(2004-2006) in Norway in 1990 to that in 1992?
Offer a terse response. 1.48. What is the ratio of the Production index(2004-2006) in Saudi Arabia in 1990 to that in 1992?
Make the answer very short. 0.94. What is the ratio of the Production index(2004-2006) of Sweden in 1990 to that in 1992?
Offer a terse response. 1.5. What is the ratio of the Production index(2004-2006) of Low & middle income in 1990 to that in 1993?
Offer a terse response. 0.9. What is the ratio of the Production index(2004-2006) in Norway in 1990 to that in 1993?
Provide a short and direct response. 1.2. What is the ratio of the Production index(2004-2006) in Saudi Arabia in 1990 to that in 1993?
Give a very brief answer. 0.91. What is the ratio of the Production index(2004-2006) in Sweden in 1990 to that in 1993?
Provide a succinct answer. 1.18. What is the ratio of the Production index(2004-2006) of Low & middle income in 1990 to that in 1994?
Keep it short and to the point. 0.89. What is the ratio of the Production index(2004-2006) of Norway in 1990 to that in 1994?
Keep it short and to the point. 1.28. What is the ratio of the Production index(2004-2006) of Saudi Arabia in 1990 to that in 1994?
Provide a short and direct response. 0.91. What is the ratio of the Production index(2004-2006) of Sweden in 1990 to that in 1994?
Your answer should be very brief. 1.43. What is the ratio of the Production index(2004-2006) of Low & middle income in 1990 to that in 1995?
Provide a short and direct response. 0.85. What is the ratio of the Production index(2004-2006) in Norway in 1990 to that in 1995?
Provide a short and direct response. 1.36. What is the ratio of the Production index(2004-2006) of Saudi Arabia in 1990 to that in 1995?
Keep it short and to the point. 1.03. What is the ratio of the Production index(2004-2006) of Sweden in 1990 to that in 1995?
Your answer should be compact. 1.37. What is the ratio of the Production index(2004-2006) of Low & middle income in 1990 to that in 1996?
Ensure brevity in your answer.  0.81. What is the ratio of the Production index(2004-2006) in Norway in 1990 to that in 1996?
Provide a short and direct response. 1.35. What is the ratio of the Production index(2004-2006) of Saudi Arabia in 1990 to that in 1996?
Keep it short and to the point. 1.1. What is the ratio of the Production index(2004-2006) in Sweden in 1990 to that in 1996?
Offer a very short reply. 1.17. What is the ratio of the Production index(2004-2006) of Low & middle income in 1990 to that in 1997?
Ensure brevity in your answer.  0.8. What is the ratio of the Production index(2004-2006) of Norway in 1990 to that in 1997?
Give a very brief answer. 1.37. What is the ratio of the Production index(2004-2006) of Saudi Arabia in 1990 to that in 1997?
Provide a short and direct response. 1.03. What is the ratio of the Production index(2004-2006) of Sweden in 1990 to that in 1997?
Give a very brief answer. 1.16. What is the ratio of the Production index(2004-2006) of Low & middle income in 1991 to that in 1992?
Keep it short and to the point. 0.96. What is the ratio of the Production index(2004-2006) in Norway in 1991 to that in 1992?
Ensure brevity in your answer.  1.18. What is the ratio of the Production index(2004-2006) in Saudi Arabia in 1991 to that in 1992?
Offer a very short reply. 0.94. What is the ratio of the Production index(2004-2006) in Sweden in 1991 to that in 1992?
Your answer should be very brief. 1.12. What is the ratio of the Production index(2004-2006) of Low & middle income in 1991 to that in 1993?
Provide a short and direct response. 0.92. What is the ratio of the Production index(2004-2006) of Norway in 1991 to that in 1993?
Your response must be concise. 0.95. What is the ratio of the Production index(2004-2006) of Saudi Arabia in 1991 to that in 1993?
Make the answer very short. 0.91. What is the ratio of the Production index(2004-2006) of Sweden in 1991 to that in 1993?
Your answer should be very brief. 0.88. What is the ratio of the Production index(2004-2006) in Low & middle income in 1991 to that in 1994?
Provide a succinct answer. 0.91. What is the ratio of the Production index(2004-2006) of Norway in 1991 to that in 1994?
Ensure brevity in your answer.  1.02. What is the ratio of the Production index(2004-2006) of Saudi Arabia in 1991 to that in 1994?
Keep it short and to the point. 0.91. What is the ratio of the Production index(2004-2006) of Sweden in 1991 to that in 1994?
Make the answer very short. 1.06. What is the ratio of the Production index(2004-2006) in Low & middle income in 1991 to that in 1995?
Give a very brief answer. 0.87. What is the ratio of the Production index(2004-2006) of Norway in 1991 to that in 1995?
Offer a very short reply. 1.08. What is the ratio of the Production index(2004-2006) in Saudi Arabia in 1991 to that in 1995?
Keep it short and to the point. 1.03. What is the ratio of the Production index(2004-2006) in Low & middle income in 1991 to that in 1996?
Your answer should be compact. 0.83. What is the ratio of the Production index(2004-2006) in Norway in 1991 to that in 1996?
Your response must be concise. 1.07. What is the ratio of the Production index(2004-2006) of Saudi Arabia in 1991 to that in 1996?
Offer a very short reply. 1.1. What is the ratio of the Production index(2004-2006) in Sweden in 1991 to that in 1996?
Offer a terse response. 0.87. What is the ratio of the Production index(2004-2006) of Low & middle income in 1991 to that in 1997?
Your answer should be compact. 0.82. What is the ratio of the Production index(2004-2006) of Norway in 1991 to that in 1997?
Ensure brevity in your answer.  1.09. What is the ratio of the Production index(2004-2006) in Saudi Arabia in 1991 to that in 1997?
Offer a very short reply. 1.03. What is the ratio of the Production index(2004-2006) of Sweden in 1991 to that in 1997?
Offer a very short reply. 0.86. What is the ratio of the Production index(2004-2006) in Low & middle income in 1992 to that in 1993?
Ensure brevity in your answer.  0.97. What is the ratio of the Production index(2004-2006) in Norway in 1992 to that in 1993?
Your response must be concise. 0.81. What is the ratio of the Production index(2004-2006) in Saudi Arabia in 1992 to that in 1993?
Offer a very short reply. 0.96. What is the ratio of the Production index(2004-2006) of Sweden in 1992 to that in 1993?
Your answer should be compact. 0.79. What is the ratio of the Production index(2004-2006) of Low & middle income in 1992 to that in 1994?
Your answer should be compact. 0.95. What is the ratio of the Production index(2004-2006) of Norway in 1992 to that in 1994?
Your response must be concise. 0.86. What is the ratio of the Production index(2004-2006) of Saudi Arabia in 1992 to that in 1994?
Provide a succinct answer. 0.97. What is the ratio of the Production index(2004-2006) of Sweden in 1992 to that in 1994?
Your answer should be very brief. 0.95. What is the ratio of the Production index(2004-2006) in Low & middle income in 1992 to that in 1995?
Keep it short and to the point. 0.91. What is the ratio of the Production index(2004-2006) in Norway in 1992 to that in 1995?
Your answer should be compact. 0.92. What is the ratio of the Production index(2004-2006) in Saudi Arabia in 1992 to that in 1995?
Provide a short and direct response. 1.09. What is the ratio of the Production index(2004-2006) in Sweden in 1992 to that in 1995?
Offer a very short reply. 0.92. What is the ratio of the Production index(2004-2006) of Low & middle income in 1992 to that in 1996?
Provide a succinct answer. 0.87. What is the ratio of the Production index(2004-2006) in Norway in 1992 to that in 1996?
Offer a very short reply. 0.91. What is the ratio of the Production index(2004-2006) in Saudi Arabia in 1992 to that in 1996?
Offer a very short reply. 1.17. What is the ratio of the Production index(2004-2006) of Sweden in 1992 to that in 1996?
Provide a short and direct response. 0.78. What is the ratio of the Production index(2004-2006) of Low & middle income in 1992 to that in 1997?
Give a very brief answer. 0.86. What is the ratio of the Production index(2004-2006) of Norway in 1992 to that in 1997?
Provide a succinct answer. 0.93. What is the ratio of the Production index(2004-2006) in Saudi Arabia in 1992 to that in 1997?
Ensure brevity in your answer.  1.09. What is the ratio of the Production index(2004-2006) of Sweden in 1992 to that in 1997?
Provide a succinct answer. 0.78. What is the ratio of the Production index(2004-2006) in Low & middle income in 1993 to that in 1994?
Provide a short and direct response. 0.99. What is the ratio of the Production index(2004-2006) in Norway in 1993 to that in 1994?
Your answer should be very brief. 1.06. What is the ratio of the Production index(2004-2006) of Saudi Arabia in 1993 to that in 1994?
Offer a very short reply. 1.01. What is the ratio of the Production index(2004-2006) in Sweden in 1993 to that in 1994?
Offer a very short reply. 1.22. What is the ratio of the Production index(2004-2006) of Low & middle income in 1993 to that in 1995?
Keep it short and to the point. 0.95. What is the ratio of the Production index(2004-2006) of Norway in 1993 to that in 1995?
Offer a terse response. 1.13. What is the ratio of the Production index(2004-2006) in Saudi Arabia in 1993 to that in 1995?
Ensure brevity in your answer.  1.13. What is the ratio of the Production index(2004-2006) in Sweden in 1993 to that in 1995?
Keep it short and to the point. 1.17. What is the ratio of the Production index(2004-2006) of Low & middle income in 1993 to that in 1996?
Keep it short and to the point. 0.9. What is the ratio of the Production index(2004-2006) of Norway in 1993 to that in 1996?
Offer a terse response. 1.12. What is the ratio of the Production index(2004-2006) of Saudi Arabia in 1993 to that in 1996?
Offer a very short reply. 1.22. What is the ratio of the Production index(2004-2006) of Sweden in 1993 to that in 1996?
Give a very brief answer. 1. What is the ratio of the Production index(2004-2006) in Low & middle income in 1993 to that in 1997?
Keep it short and to the point. 0.89. What is the ratio of the Production index(2004-2006) in Norway in 1993 to that in 1997?
Offer a very short reply. 1.14. What is the ratio of the Production index(2004-2006) in Saudi Arabia in 1993 to that in 1997?
Your answer should be compact. 1.14. What is the ratio of the Production index(2004-2006) of Sweden in 1993 to that in 1997?
Give a very brief answer. 0.99. What is the ratio of the Production index(2004-2006) of Low & middle income in 1994 to that in 1995?
Your answer should be very brief. 0.96. What is the ratio of the Production index(2004-2006) of Norway in 1994 to that in 1995?
Ensure brevity in your answer.  1.06. What is the ratio of the Production index(2004-2006) in Saudi Arabia in 1994 to that in 1995?
Your answer should be compact. 1.12. What is the ratio of the Production index(2004-2006) in Sweden in 1994 to that in 1995?
Your answer should be very brief. 0.96. What is the ratio of the Production index(2004-2006) of Low & middle income in 1994 to that in 1996?
Your answer should be very brief. 0.91. What is the ratio of the Production index(2004-2006) of Norway in 1994 to that in 1996?
Give a very brief answer. 1.06. What is the ratio of the Production index(2004-2006) in Saudi Arabia in 1994 to that in 1996?
Ensure brevity in your answer.  1.21. What is the ratio of the Production index(2004-2006) in Sweden in 1994 to that in 1996?
Provide a succinct answer. 0.82. What is the ratio of the Production index(2004-2006) in Low & middle income in 1994 to that in 1997?
Your answer should be compact. 0.9. What is the ratio of the Production index(2004-2006) of Norway in 1994 to that in 1997?
Your response must be concise. 1.07. What is the ratio of the Production index(2004-2006) in Saudi Arabia in 1994 to that in 1997?
Your response must be concise. 1.13. What is the ratio of the Production index(2004-2006) in Sweden in 1994 to that in 1997?
Your answer should be compact. 0.81. What is the ratio of the Production index(2004-2006) in Low & middle income in 1995 to that in 1996?
Your answer should be very brief. 0.95. What is the ratio of the Production index(2004-2006) of Norway in 1995 to that in 1996?
Offer a terse response. 0.99. What is the ratio of the Production index(2004-2006) of Saudi Arabia in 1995 to that in 1996?
Your answer should be very brief. 1.08. What is the ratio of the Production index(2004-2006) in Sweden in 1995 to that in 1996?
Your answer should be very brief. 0.86. What is the ratio of the Production index(2004-2006) of Low & middle income in 1995 to that in 1997?
Your answer should be compact. 0.94. What is the ratio of the Production index(2004-2006) in Norway in 1995 to that in 1997?
Offer a very short reply. 1.01. What is the ratio of the Production index(2004-2006) in Sweden in 1995 to that in 1997?
Make the answer very short. 0.85. What is the ratio of the Production index(2004-2006) of Low & middle income in 1996 to that in 1997?
Your answer should be compact. 0.99. What is the ratio of the Production index(2004-2006) of Norway in 1996 to that in 1997?
Your response must be concise. 1.01. What is the ratio of the Production index(2004-2006) of Saudi Arabia in 1996 to that in 1997?
Keep it short and to the point. 0.93. What is the difference between the highest and the second highest Production index(2004-2006) in Low & middle income?
Ensure brevity in your answer.  1.04. What is the difference between the highest and the second highest Production index(2004-2006) in Norway?
Your response must be concise. 22.86. What is the difference between the highest and the second highest Production index(2004-2006) of Saudi Arabia?
Your answer should be compact. 0.55. What is the difference between the highest and the second highest Production index(2004-2006) of Sweden?
Your answer should be compact. 18.17. What is the difference between the highest and the lowest Production index(2004-2006) in Low & middle income?
Offer a terse response. 15.59. What is the difference between the highest and the lowest Production index(2004-2006) of Norway?
Offer a very short reply. 44.06. What is the difference between the highest and the lowest Production index(2004-2006) of Saudi Arabia?
Make the answer very short. 16.75. What is the difference between the highest and the lowest Production index(2004-2006) in Sweden?
Ensure brevity in your answer.  43.39. 